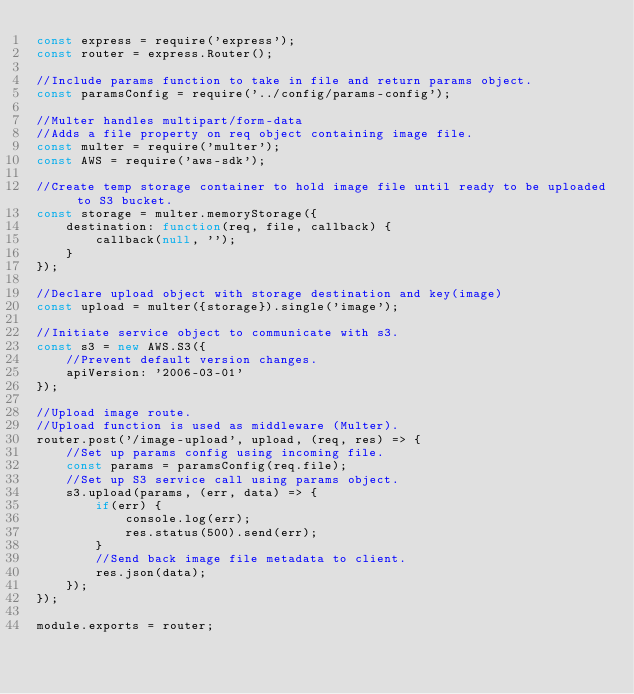<code> <loc_0><loc_0><loc_500><loc_500><_JavaScript_>const express = require('express');
const router = express.Router();

//Include params function to take in file and return params object.
const paramsConfig = require('../config/params-config');

//Multer handles multipart/form-data
//Adds a file property on req object containing image file.
const multer = require('multer');
const AWS = require('aws-sdk');

//Create temp storage container to hold image file until ready to be uploaded to S3 bucket.
const storage = multer.memoryStorage({
    destination: function(req, file, callback) {
        callback(null, '');
    }
});

//Declare upload object with storage destination and key(image)
const upload = multer({storage}).single('image');

//Initiate service object to communicate with s3.
const s3 = new AWS.S3({
    //Prevent default version changes.
    apiVersion: '2006-03-01'
});

//Upload image route.
//Upload function is used as middleware (Multer).
router.post('/image-upload', upload, (req, res) => {
    //Set up params config using incoming file.
    const params = paramsConfig(req.file);
    //Set up S3 service call using params object.
    s3.upload(params, (err, data) => {
        if(err) {
            console.log(err); 
            res.status(500).send(err);
        }
        //Send back image file metadata to client.
        res.json(data);
    });
});

module.exports = router;</code> 